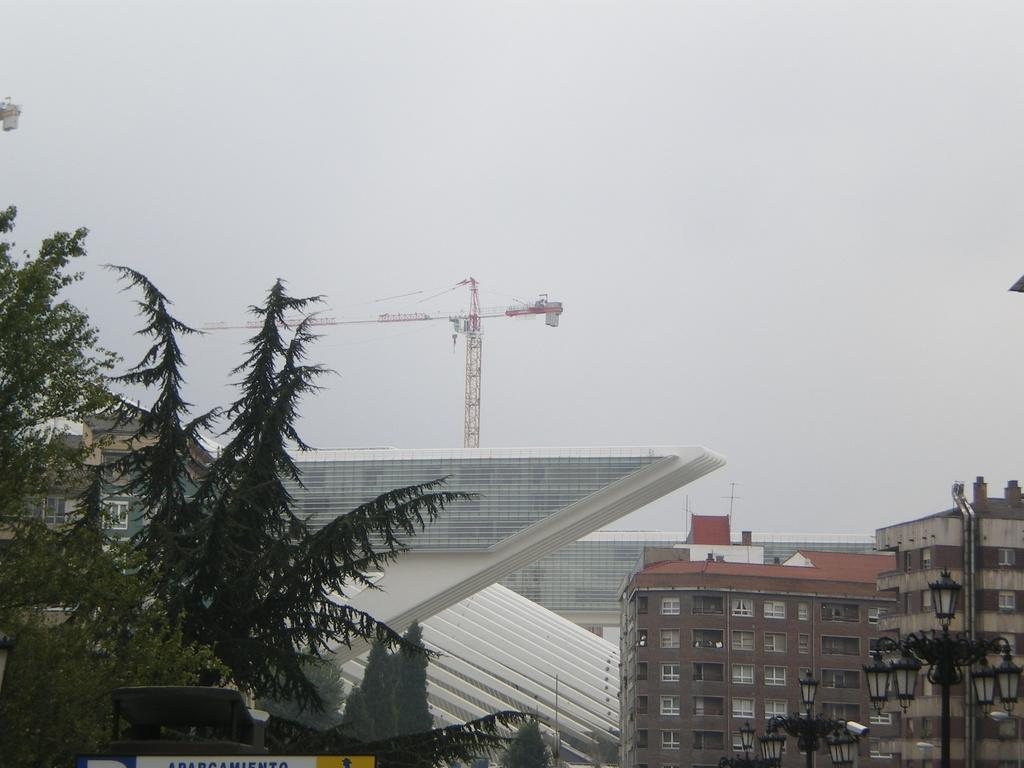What type of structures can be seen in the image? There are buildings in the image. What natural elements are present in the image? There are trees in the image. What other objects can be seen in the image? There are poles in the image. What can be seen in the background of the image? There is a tower in the background of the image. What decision does the cloud make in the image? There is no cloud present in the image, so it cannot make any decisions. How does the tower turn in the image? The tower does not turn in the image; it is stationary in the background. 